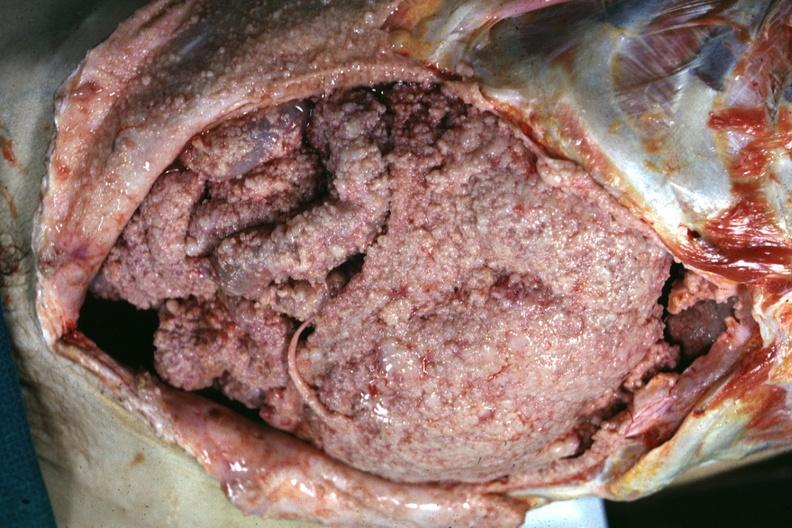s mesothelioma present?
Answer the question using a single word or phrase. Yes 